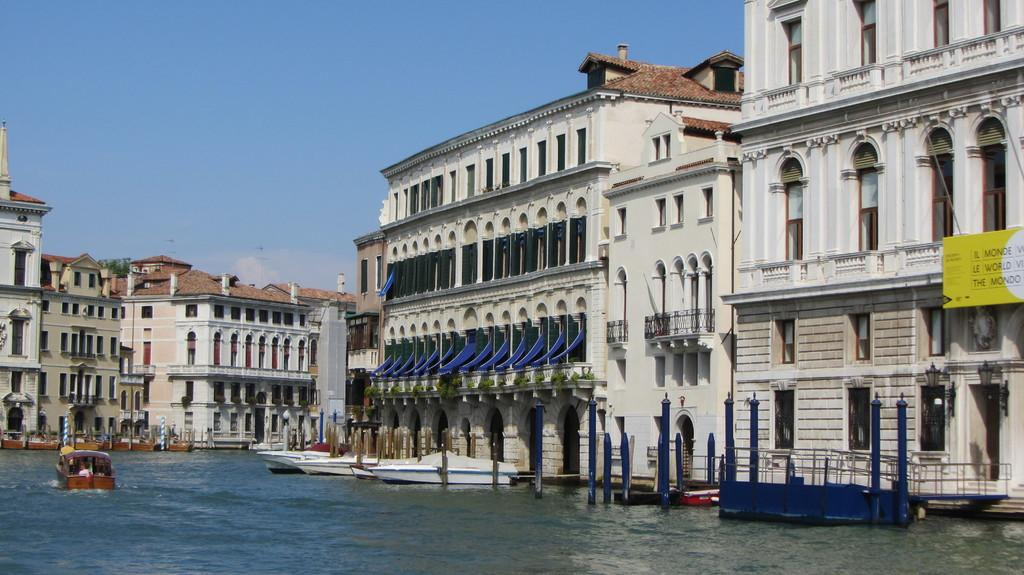What can be seen floating on the water in the image? There are boats on the water in the image. What type of structures can be seen in the image? There are buildings visible in the image. What feature is present to provide safety or support in the image? Railings are present in the image. What is located on the right side of the image? There is a hoarding on the right side of the image. What is visible in the sky in the image? Clouds are visible in the sky in the image. Where is the girl sitting in the image? There is no girl present in the image. What type of fruit is being used as a seat in the image? There is no fruit being used as a seat in the image. 